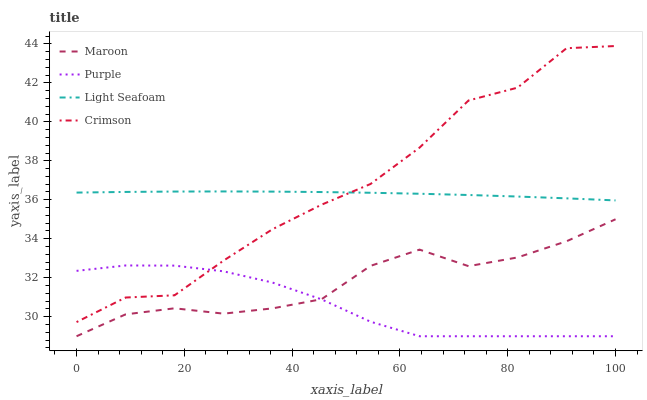Does Purple have the minimum area under the curve?
Answer yes or no. Yes. Does Crimson have the maximum area under the curve?
Answer yes or no. Yes. Does Light Seafoam have the minimum area under the curve?
Answer yes or no. No. Does Light Seafoam have the maximum area under the curve?
Answer yes or no. No. Is Light Seafoam the smoothest?
Answer yes or no. Yes. Is Crimson the roughest?
Answer yes or no. Yes. Is Crimson the smoothest?
Answer yes or no. No. Is Light Seafoam the roughest?
Answer yes or no. No. Does Crimson have the lowest value?
Answer yes or no. No. Does Crimson have the highest value?
Answer yes or no. Yes. Does Light Seafoam have the highest value?
Answer yes or no. No. Is Purple less than Light Seafoam?
Answer yes or no. Yes. Is Light Seafoam greater than Maroon?
Answer yes or no. Yes. Does Light Seafoam intersect Crimson?
Answer yes or no. Yes. Is Light Seafoam less than Crimson?
Answer yes or no. No. Is Light Seafoam greater than Crimson?
Answer yes or no. No. Does Purple intersect Light Seafoam?
Answer yes or no. No. 